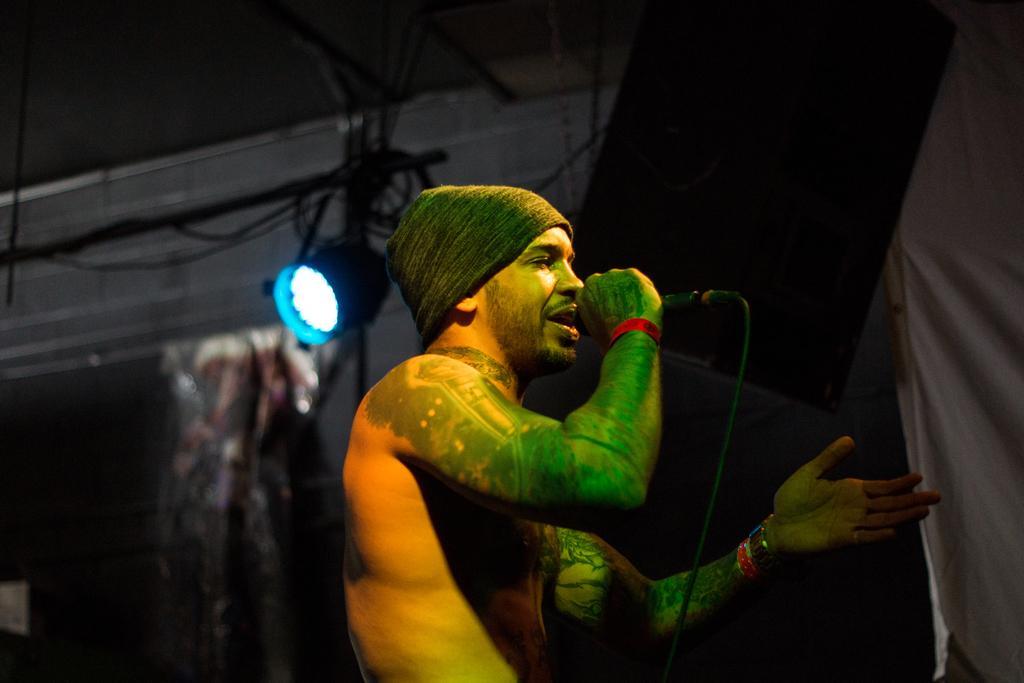How would you summarize this image in a sentence or two? In this image in the front there is a man performing holding a mic in his hand and singing. In the background there is a light and there is a curtain which is black in colour and in front of the curtain there is an object which is black in colour. 